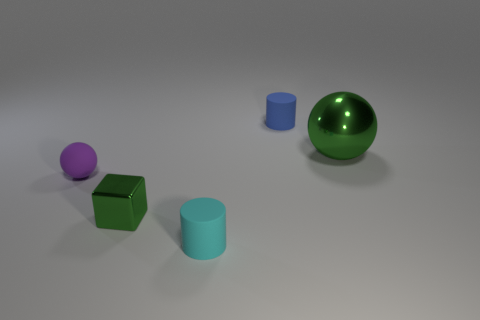There is a purple object that is the same size as the blue rubber thing; what shape is it?
Your response must be concise. Sphere. Is there a tiny matte thing of the same color as the large shiny thing?
Offer a terse response. No. Is the shape of the tiny blue object the same as the small green object?
Provide a short and direct response. No. How many large things are either purple spheres or shiny objects?
Your answer should be compact. 1. There is a large ball that is made of the same material as the tiny green object; what color is it?
Your answer should be very brief. Green. What number of objects have the same material as the small cube?
Make the answer very short. 1. There is a green metal thing behind the tiny green block; does it have the same size as the rubber cylinder behind the small metallic object?
Your answer should be very brief. No. What is the thing that is to the right of the thing behind the large metallic object made of?
Provide a succinct answer. Metal. Is the number of small matte spheres behind the blue thing less than the number of tiny blue objects that are in front of the small matte sphere?
Your response must be concise. No. What material is the big sphere that is the same color as the metal block?
Give a very brief answer. Metal. 